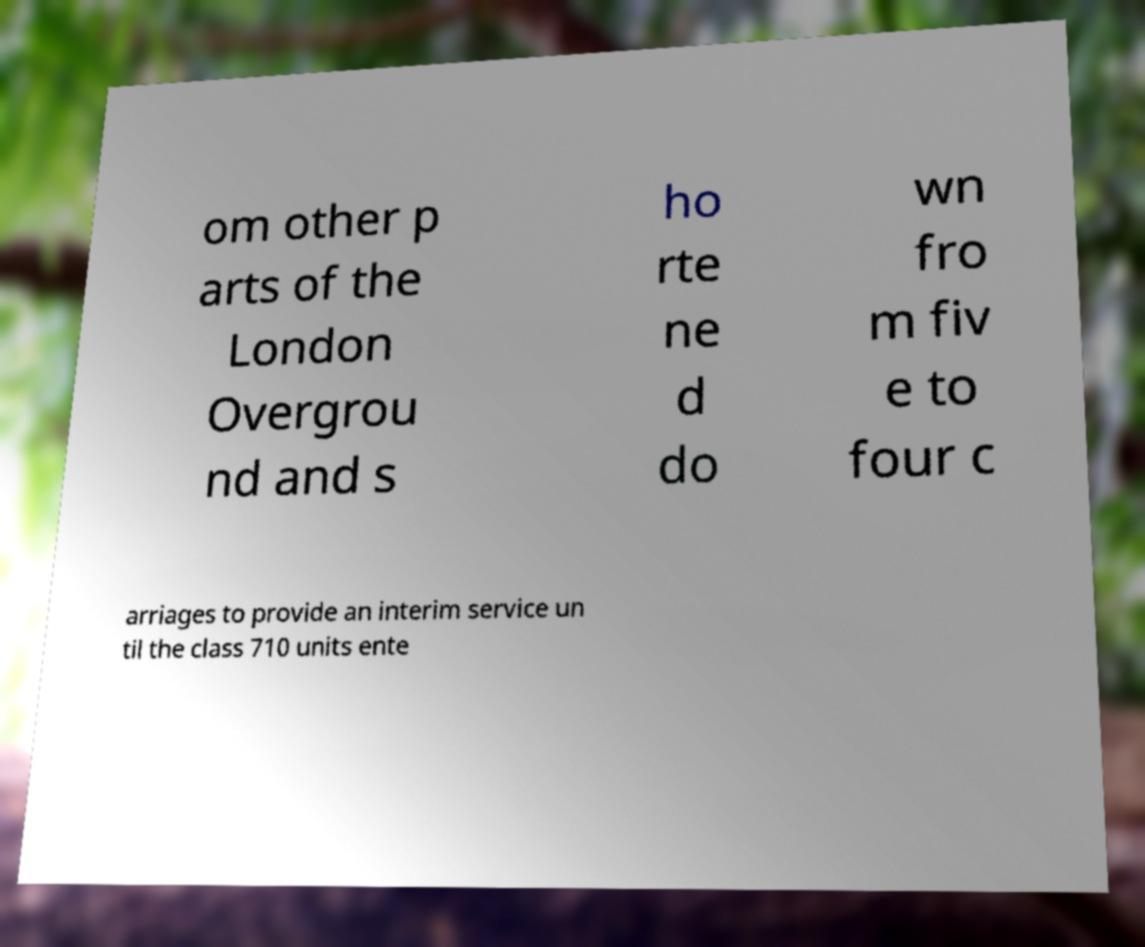I need the written content from this picture converted into text. Can you do that? om other p arts of the London Overgrou nd and s ho rte ne d do wn fro m fiv e to four c arriages to provide an interim service un til the class 710 units ente 